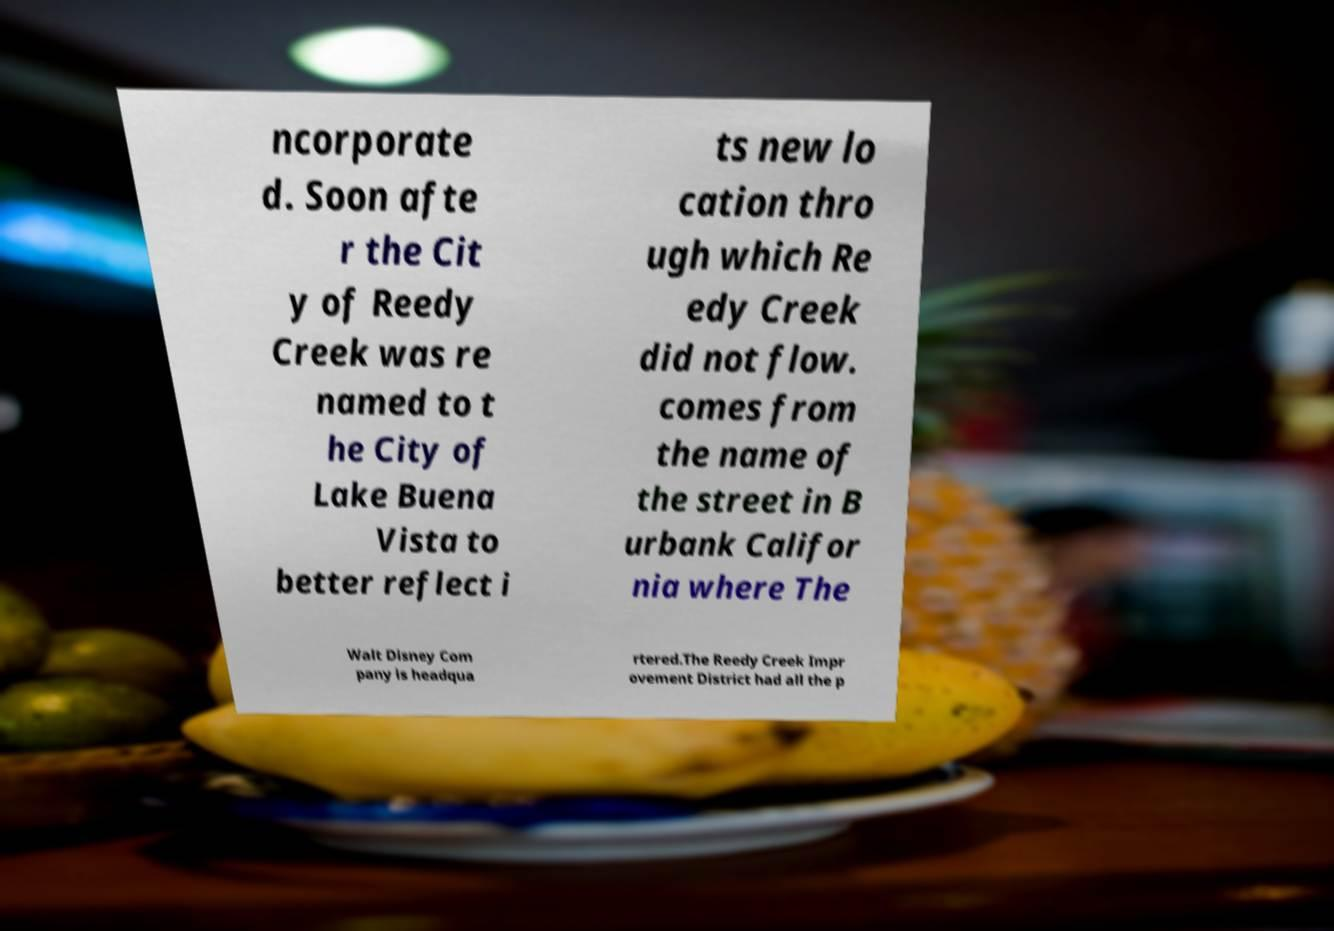Please identify and transcribe the text found in this image. ncorporate d. Soon afte r the Cit y of Reedy Creek was re named to t he City of Lake Buena Vista to better reflect i ts new lo cation thro ugh which Re edy Creek did not flow. comes from the name of the street in B urbank Califor nia where The Walt Disney Com pany is headqua rtered.The Reedy Creek Impr ovement District had all the p 